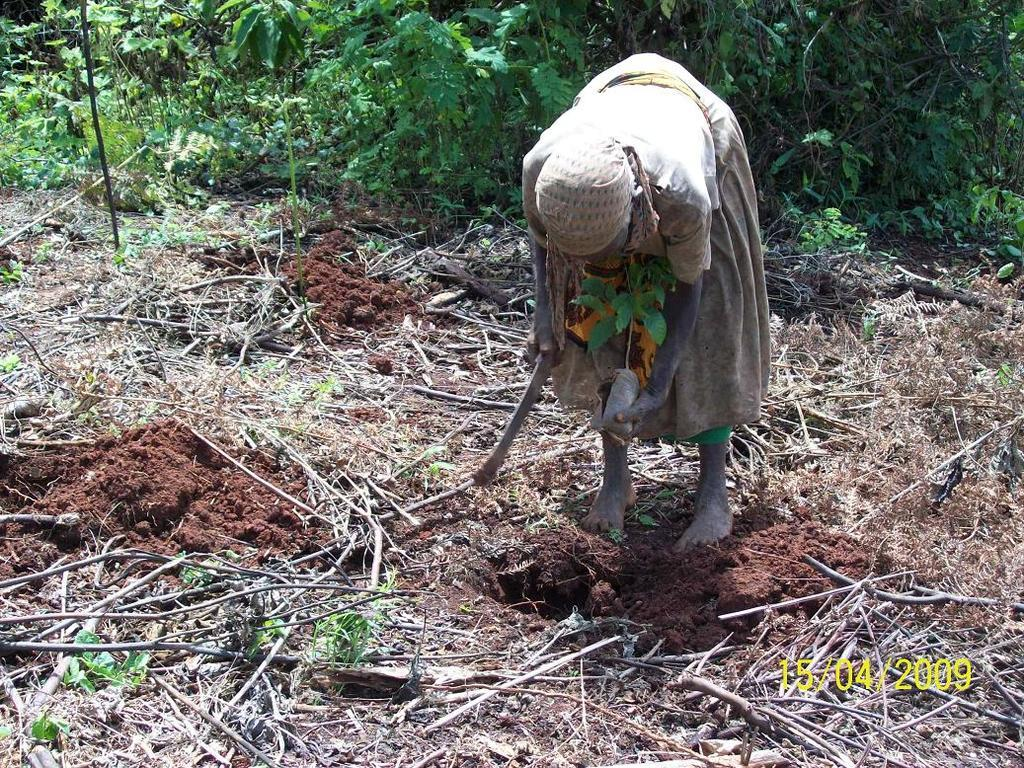Who is present in the image? There is a woman in the image. What is the woman's position in the image? The woman is on the ground. What can be seen in the background of the image? There are trees in the background of the image. What word is written on the ice in the alley in the image? There is no ice or alley present in the image, and therefore no such word can be observed. 